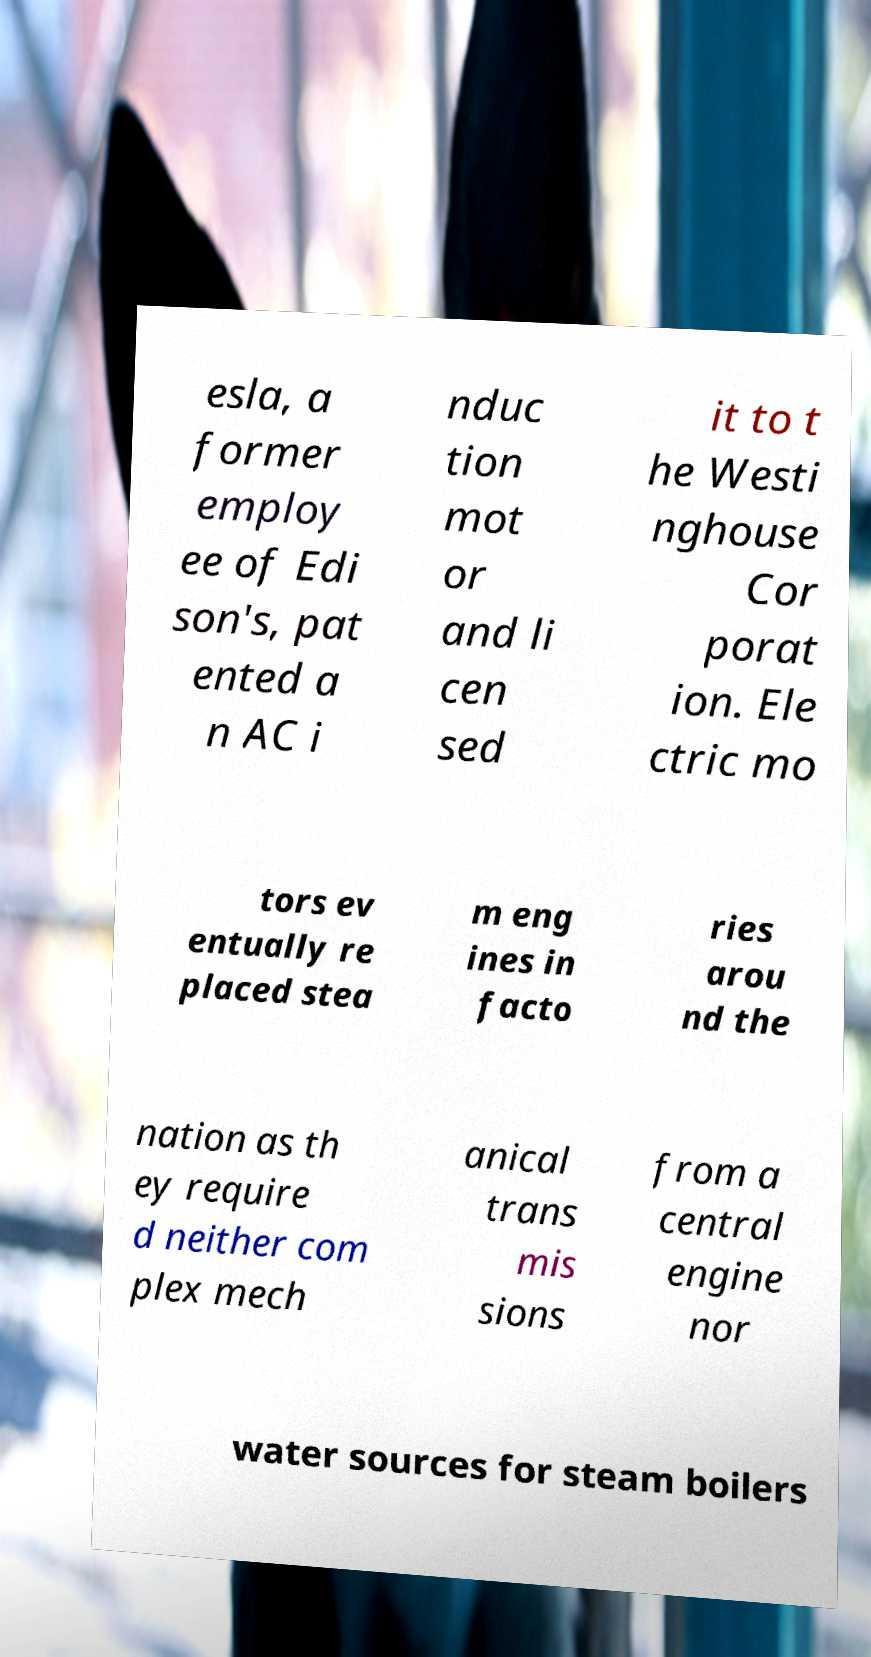Could you assist in decoding the text presented in this image and type it out clearly? esla, a former employ ee of Edi son's, pat ented a n AC i nduc tion mot or and li cen sed it to t he Westi nghouse Cor porat ion. Ele ctric mo tors ev entually re placed stea m eng ines in facto ries arou nd the nation as th ey require d neither com plex mech anical trans mis sions from a central engine nor water sources for steam boilers 